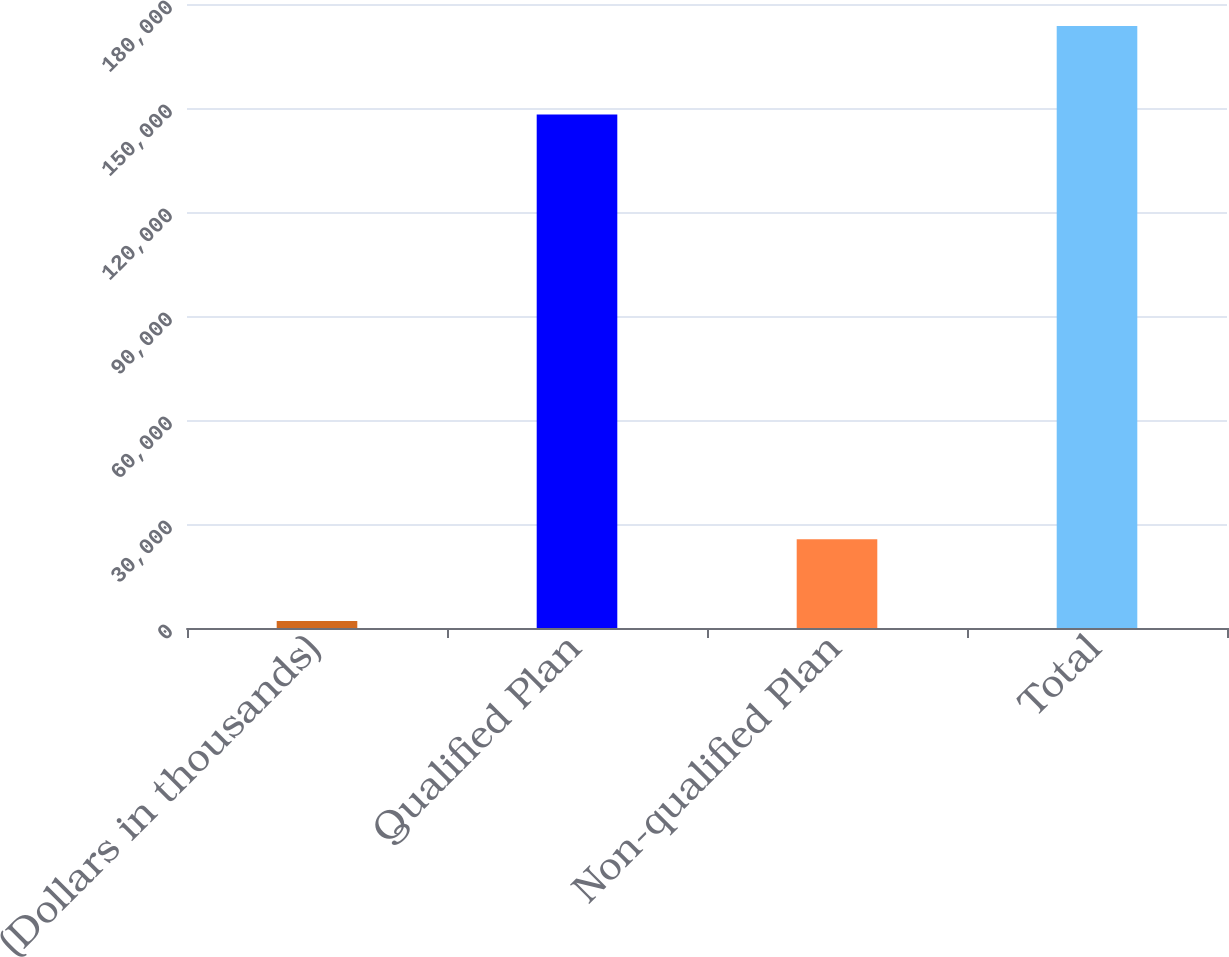<chart> <loc_0><loc_0><loc_500><loc_500><bar_chart><fcel>(Dollars in thousands)<fcel>Qualified Plan<fcel>Non-qualified Plan<fcel>Total<nl><fcel>2012<fcel>148107<fcel>25579<fcel>173686<nl></chart> 